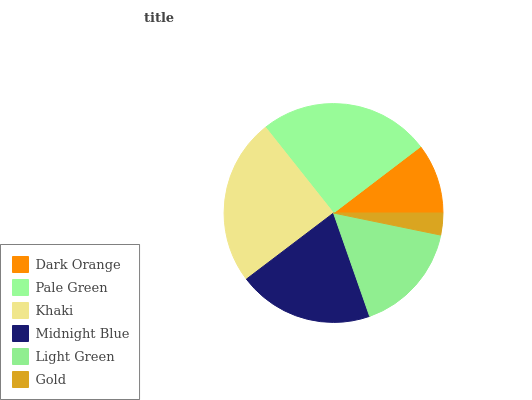Is Gold the minimum?
Answer yes or no. Yes. Is Pale Green the maximum?
Answer yes or no. Yes. Is Khaki the minimum?
Answer yes or no. No. Is Khaki the maximum?
Answer yes or no. No. Is Pale Green greater than Khaki?
Answer yes or no. Yes. Is Khaki less than Pale Green?
Answer yes or no. Yes. Is Khaki greater than Pale Green?
Answer yes or no. No. Is Pale Green less than Khaki?
Answer yes or no. No. Is Midnight Blue the high median?
Answer yes or no. Yes. Is Light Green the low median?
Answer yes or no. Yes. Is Light Green the high median?
Answer yes or no. No. Is Dark Orange the low median?
Answer yes or no. No. 